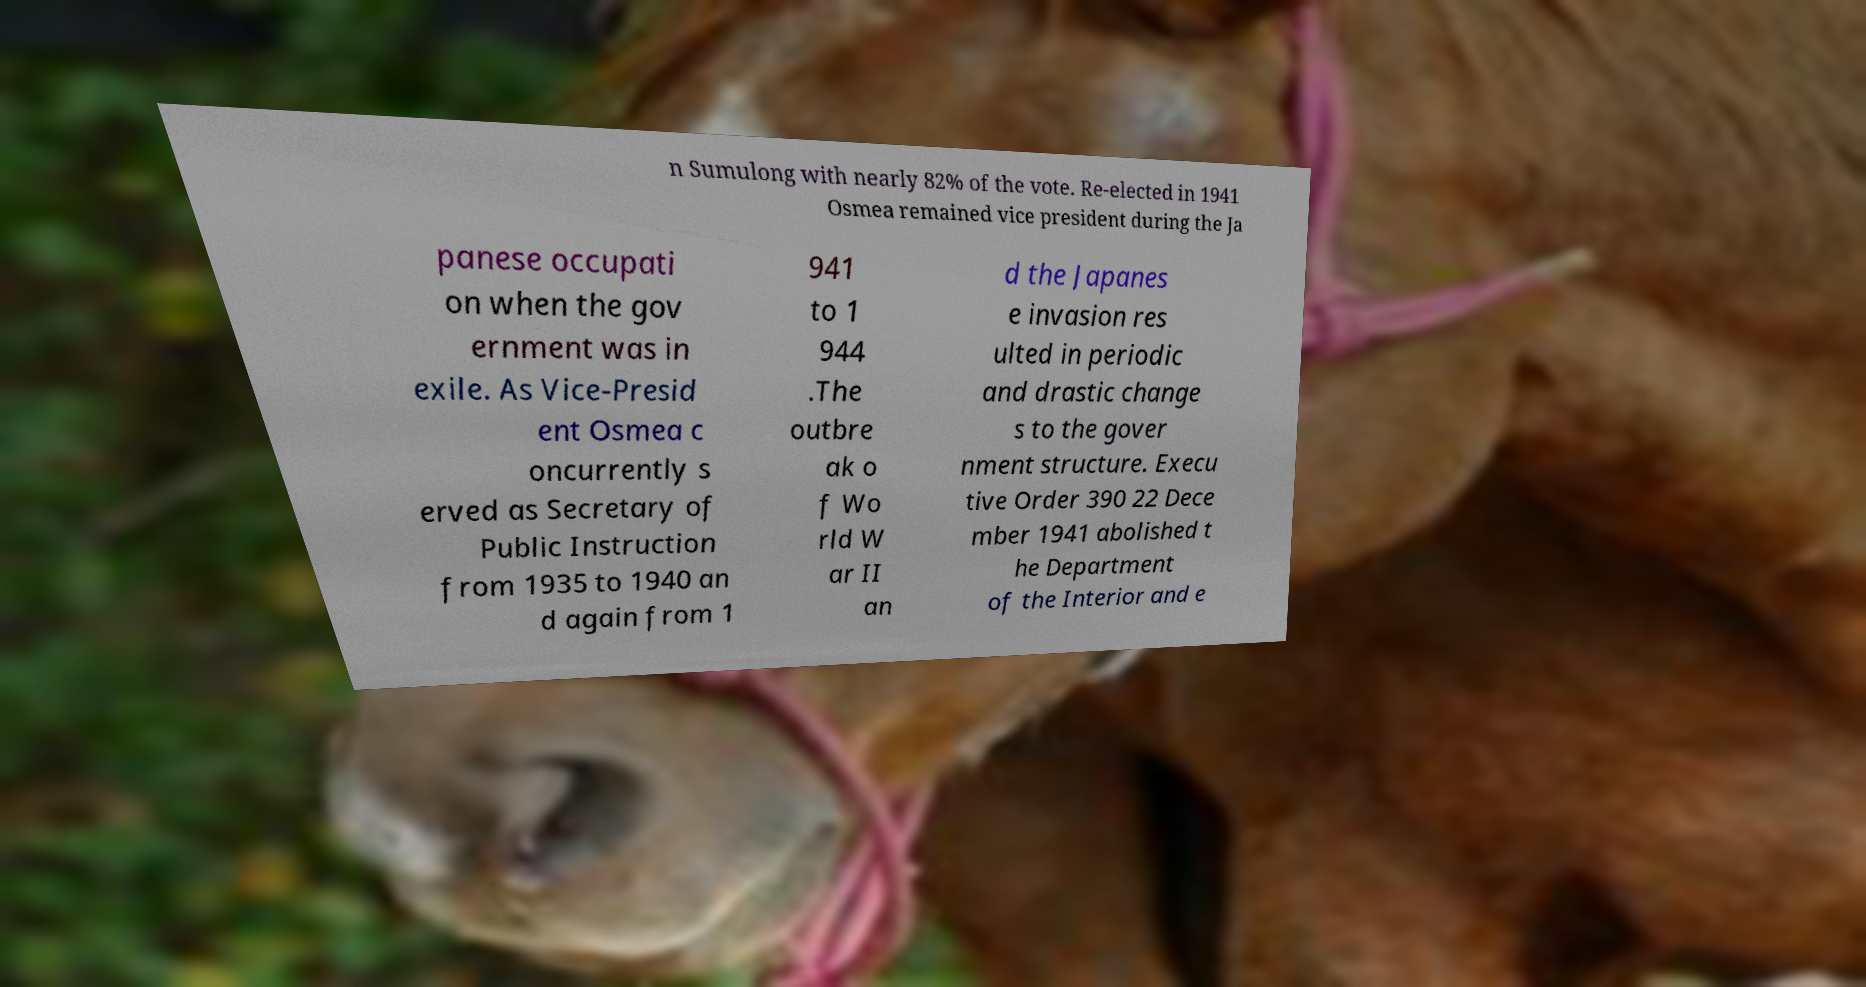I need the written content from this picture converted into text. Can you do that? n Sumulong with nearly 82% of the vote. Re-elected in 1941 Osmea remained vice president during the Ja panese occupati on when the gov ernment was in exile. As Vice-Presid ent Osmea c oncurrently s erved as Secretary of Public Instruction from 1935 to 1940 an d again from 1 941 to 1 944 .The outbre ak o f Wo rld W ar II an d the Japanes e invasion res ulted in periodic and drastic change s to the gover nment structure. Execu tive Order 390 22 Dece mber 1941 abolished t he Department of the Interior and e 